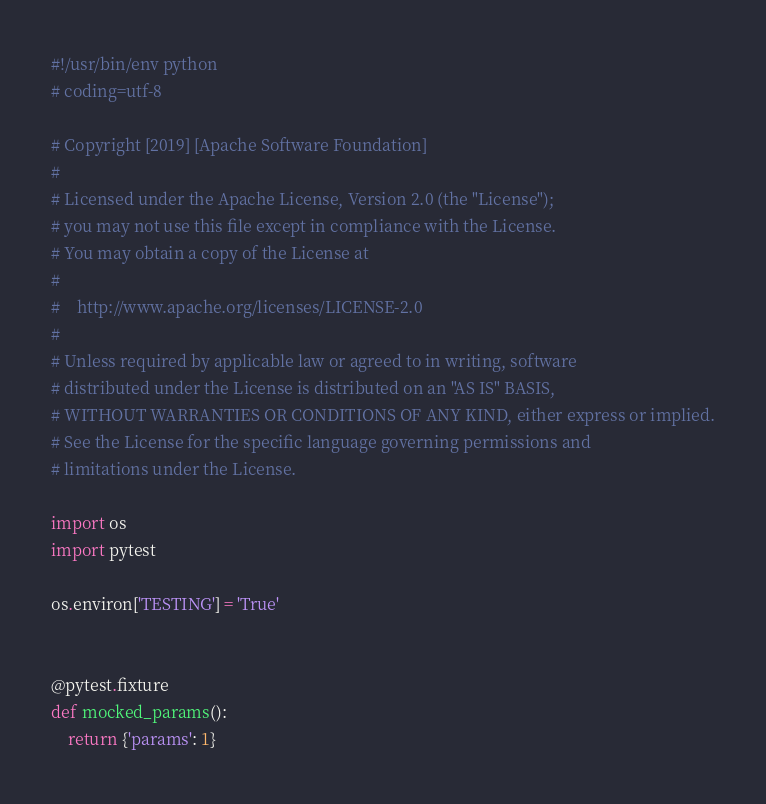Convert code to text. <code><loc_0><loc_0><loc_500><loc_500><_Python_>#!/usr/bin/env python
# coding=utf-8

# Copyright [2019] [Apache Software Foundation]
#
# Licensed under the Apache License, Version 2.0 (the "License");
# you may not use this file except in compliance with the License.
# You may obtain a copy of the License at
#
#    http://www.apache.org/licenses/LICENSE-2.0
#
# Unless required by applicable law or agreed to in writing, software
# distributed under the License is distributed on an "AS IS" BASIS,
# WITHOUT WARRANTIES OR CONDITIONS OF ANY KIND, either express or implied.
# See the License for the specific language governing permissions and
# limitations under the License.

import os
import pytest

os.environ['TESTING'] = 'True'


@pytest.fixture
def mocked_params():
    return {'params': 1}
</code> 